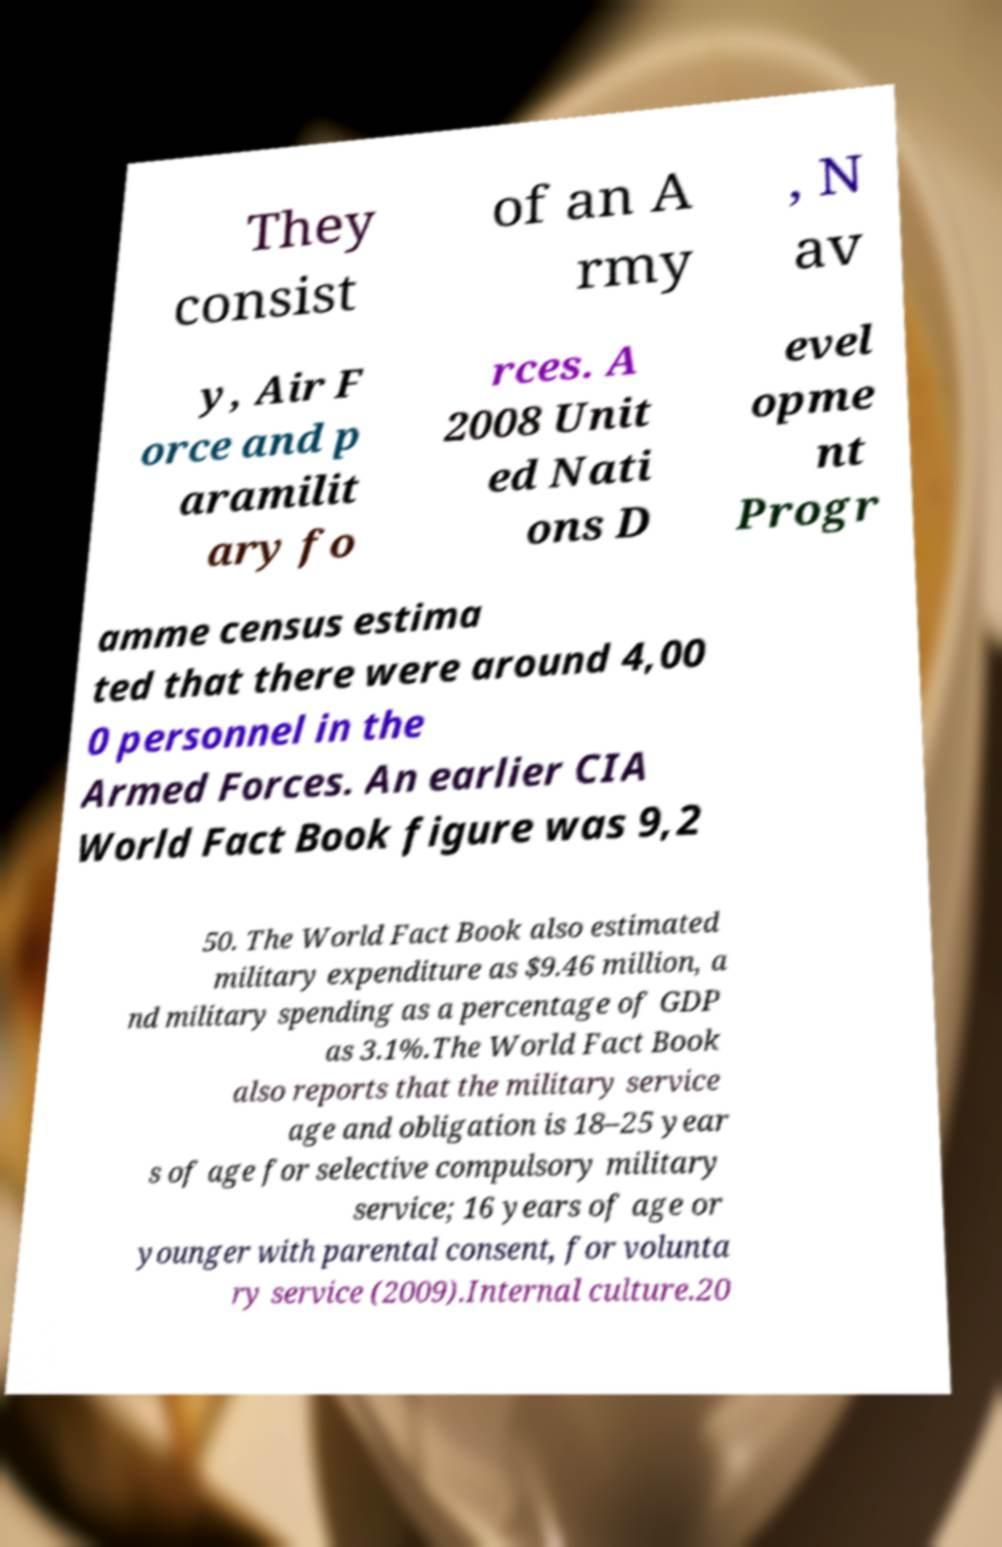There's text embedded in this image that I need extracted. Can you transcribe it verbatim? They consist of an A rmy , N av y, Air F orce and p aramilit ary fo rces. A 2008 Unit ed Nati ons D evel opme nt Progr amme census estima ted that there were around 4,00 0 personnel in the Armed Forces. An earlier CIA World Fact Book figure was 9,2 50. The World Fact Book also estimated military expenditure as $9.46 million, a nd military spending as a percentage of GDP as 3.1%.The World Fact Book also reports that the military service age and obligation is 18–25 year s of age for selective compulsory military service; 16 years of age or younger with parental consent, for volunta ry service (2009).Internal culture.20 